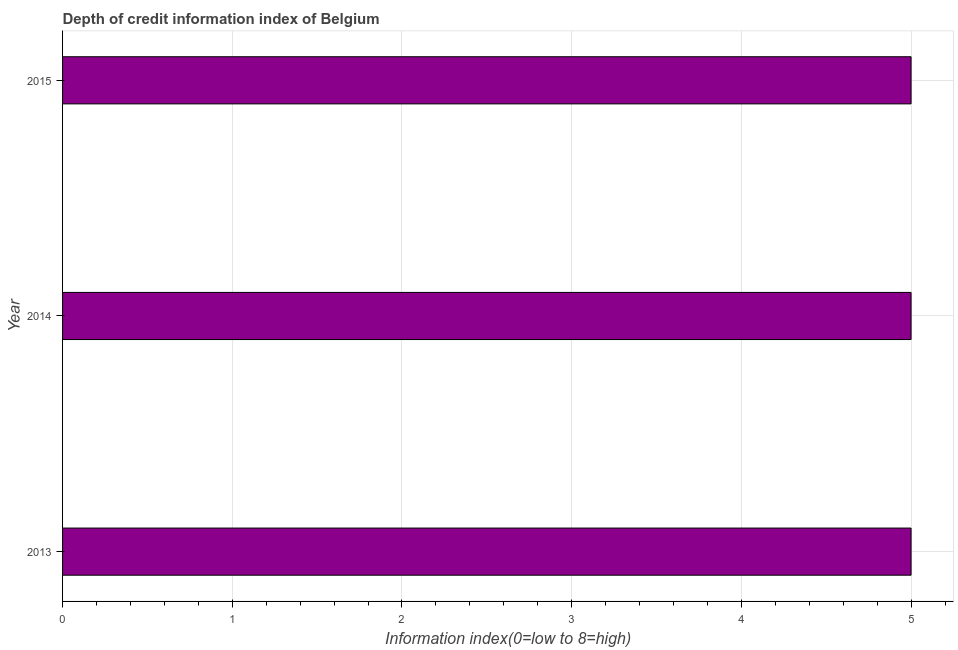What is the title of the graph?
Provide a short and direct response. Depth of credit information index of Belgium. What is the label or title of the X-axis?
Your answer should be very brief. Information index(0=low to 8=high). Across all years, what is the minimum depth of credit information index?
Offer a terse response. 5. In which year was the depth of credit information index maximum?
Provide a short and direct response. 2013. What is the average depth of credit information index per year?
Your answer should be very brief. 5. What is the median depth of credit information index?
Provide a short and direct response. 5. Do a majority of the years between 2015 and 2014 (inclusive) have depth of credit information index greater than 1.6 ?
Keep it short and to the point. No. Is the sum of the depth of credit information index in 2013 and 2014 greater than the maximum depth of credit information index across all years?
Make the answer very short. Yes. What is the difference between the highest and the lowest depth of credit information index?
Offer a very short reply. 0. In how many years, is the depth of credit information index greater than the average depth of credit information index taken over all years?
Provide a succinct answer. 0. How many bars are there?
Keep it short and to the point. 3. Are all the bars in the graph horizontal?
Make the answer very short. Yes. How many years are there in the graph?
Make the answer very short. 3. What is the difference between two consecutive major ticks on the X-axis?
Offer a very short reply. 1. Are the values on the major ticks of X-axis written in scientific E-notation?
Give a very brief answer. No. What is the Information index(0=low to 8=high) in 2014?
Provide a short and direct response. 5. What is the difference between the Information index(0=low to 8=high) in 2013 and 2014?
Give a very brief answer. 0. What is the difference between the Information index(0=low to 8=high) in 2013 and 2015?
Provide a succinct answer. 0. What is the difference between the Information index(0=low to 8=high) in 2014 and 2015?
Your response must be concise. 0. What is the ratio of the Information index(0=low to 8=high) in 2013 to that in 2014?
Provide a short and direct response. 1. What is the ratio of the Information index(0=low to 8=high) in 2013 to that in 2015?
Give a very brief answer. 1. What is the ratio of the Information index(0=low to 8=high) in 2014 to that in 2015?
Give a very brief answer. 1. 